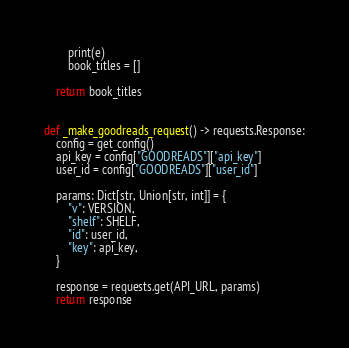Convert code to text. <code><loc_0><loc_0><loc_500><loc_500><_Python_>        print(e)
        book_titles = []

    return book_titles


def _make_goodreads_request() -> requests.Response:
    config = get_config()
    api_key = config["GOODREADS"]["api_key"]
    user_id = config["GOODREADS"]["user_id"]

    params: Dict[str, Union[str, int]] = {
        "v": VERSION,
        "shelf": SHELF,
        "id": user_id,
        "key": api_key,
    }

    response = requests.get(API_URL, params)
    return response
</code> 